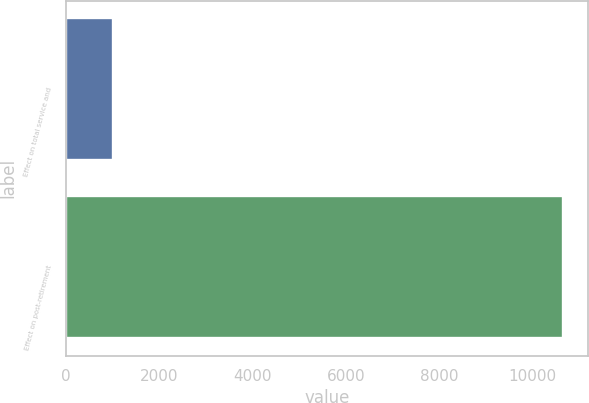Convert chart. <chart><loc_0><loc_0><loc_500><loc_500><bar_chart><fcel>Effect on total service and<fcel>Effect on post-retirement<nl><fcel>1009<fcel>10664<nl></chart> 